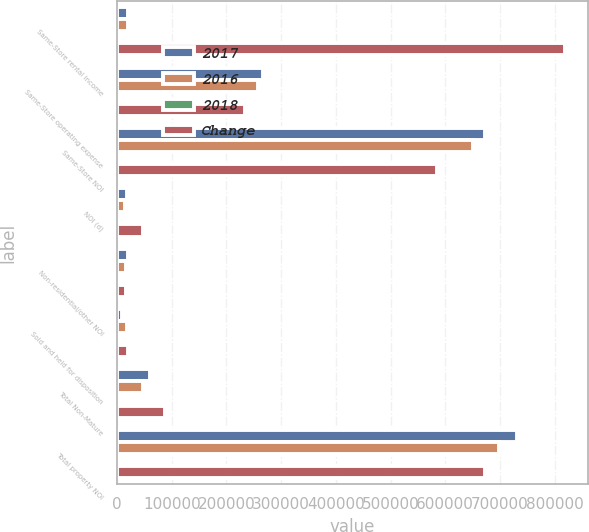Convert chart to OTSL. <chart><loc_0><loc_0><loc_500><loc_500><stacked_bar_chart><ecel><fcel>Same-Store rental income<fcel>Same-Store operating expense<fcel>Same-Store NOI<fcel>NOI (d)<fcel>Non-residential/other NOI<fcel>Sold and held for disposition<fcel>Total Non-Mature<fcel>Total property NOI<nl><fcel>2017<fcel>20124.5<fcel>267332<fcel>672394<fcel>18427<fcel>20530<fcel>9543<fcel>59721<fcel>732115<nl><fcel>2016<fcel>20124.5<fcel>257919<fcel>650442<fcel>13767<fcel>16640<fcel>17949<fcel>48061<fcel>698503<nl><fcel>2018<fcel>3.5<fcel>3.6<fcel>3.4<fcel>33.8<fcel>23.4<fcel>46.8<fcel>24.3<fcel>4.8<nl><fcel>Change<fcel>819962<fcel>234385<fcel>585577<fcel>47711<fcel>16244<fcel>19719<fcel>87508<fcel>673085<nl></chart> 